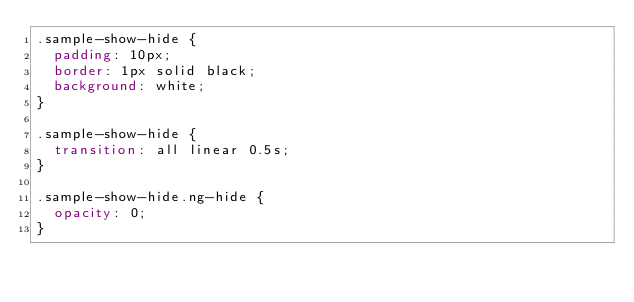Convert code to text. <code><loc_0><loc_0><loc_500><loc_500><_CSS_>.sample-show-hide {
  padding: 10px;
  border: 1px solid black;
  background: white;
}

.sample-show-hide {
  transition: all linear 0.5s;
}

.sample-show-hide.ng-hide {
  opacity: 0;
}</code> 